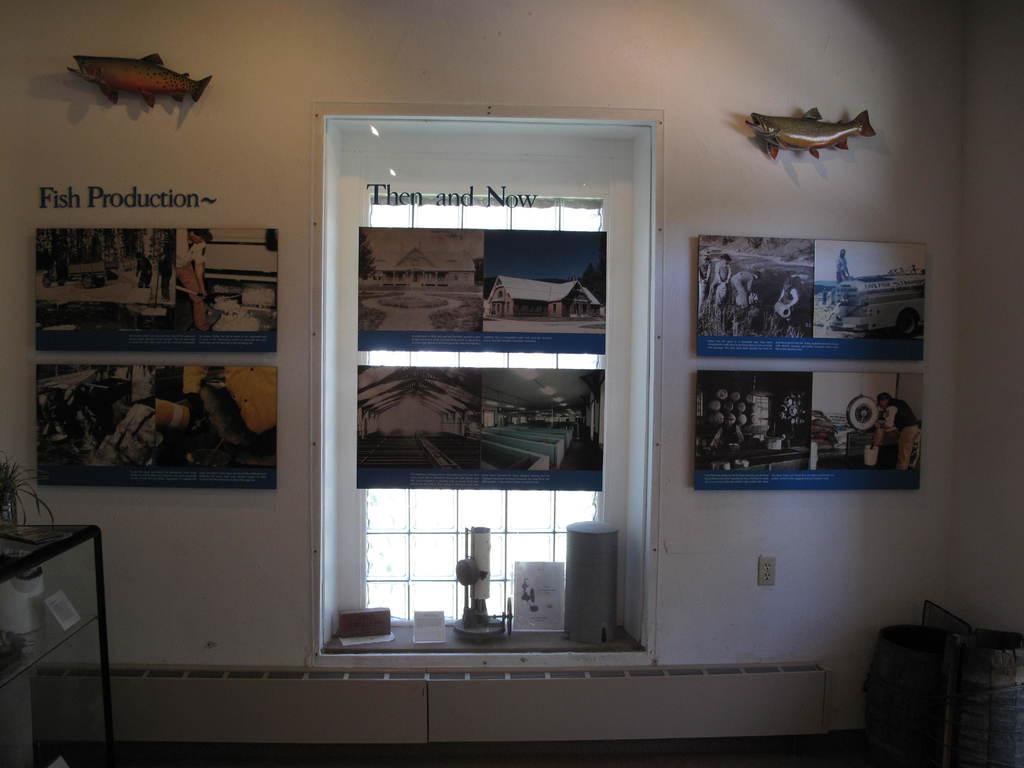What type of objects can be seen in the image? There are photo frames, fish toys, a plant, and some objects in the image. Where are the photo frames located in the image? The photo frames are in the image. What is on the wall in the image? Fish toys are on the wall in the image. Can you describe the window in the image? There is a window in the image. What is on the table in the image? There is a plant on the table in the image. What color is the bead that is being folded in the image? There is no bead or folding activity present in the image. What is the chance of winning a prize in the image? There is no reference to a prize or chance in the image. 